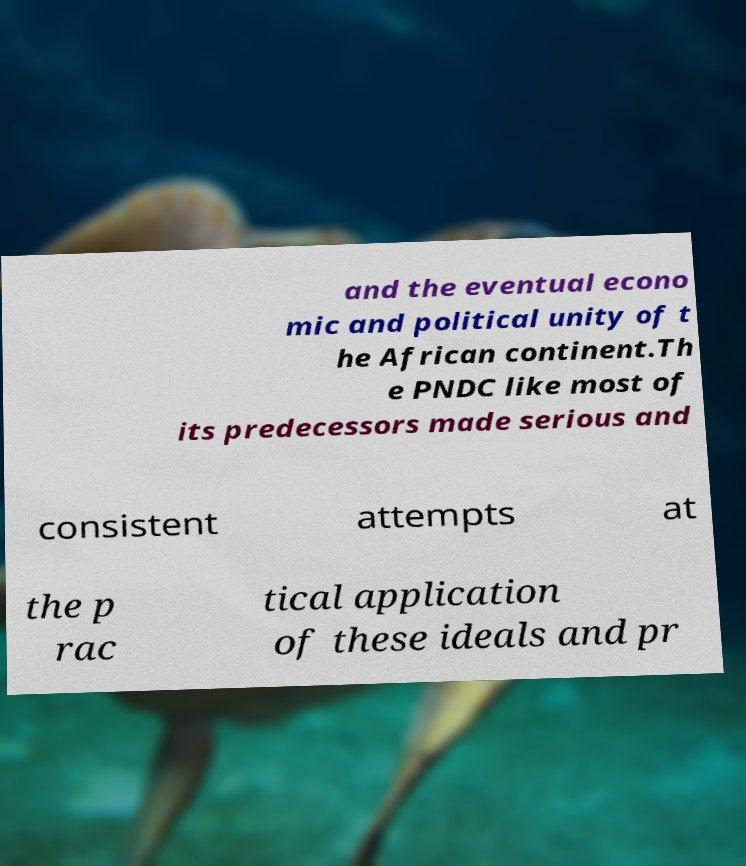Could you extract and type out the text from this image? and the eventual econo mic and political unity of t he African continent.Th e PNDC like most of its predecessors made serious and consistent attempts at the p rac tical application of these ideals and pr 